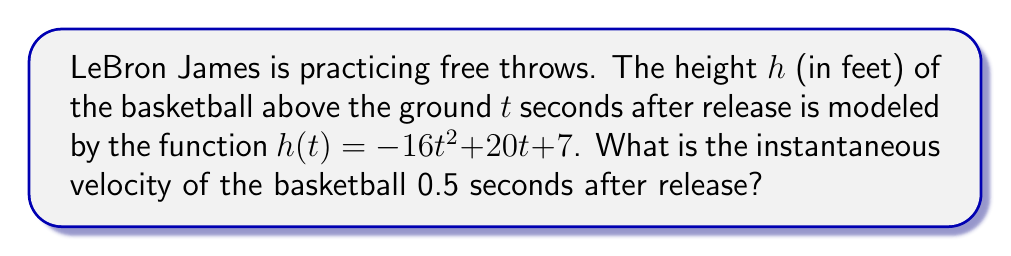Show me your answer to this math problem. To find the instantaneous velocity, we need to calculate the derivative of the height function and evaluate it at $t = 0.5$ seconds.

Step 1: Find the derivative of $h(t)$.
The height function is $h(t) = -16t^2 + 20t + 7$
Using the power rule and constant rule, we get:
$$h'(t) = -32t + 20$$

Step 2: The instantaneous velocity is given by $h'(t)$ at $t = 0.5$ seconds.
Substitute $t = 0.5$ into $h'(t)$:
$$h'(0.5) = -32(0.5) + 20$$

Step 3: Simplify the expression:
$$h'(0.5) = -16 + 20 = 4$$

Therefore, the instantaneous velocity of the basketball 0.5 seconds after release is 4 feet per second.
Answer: $4$ ft/s 